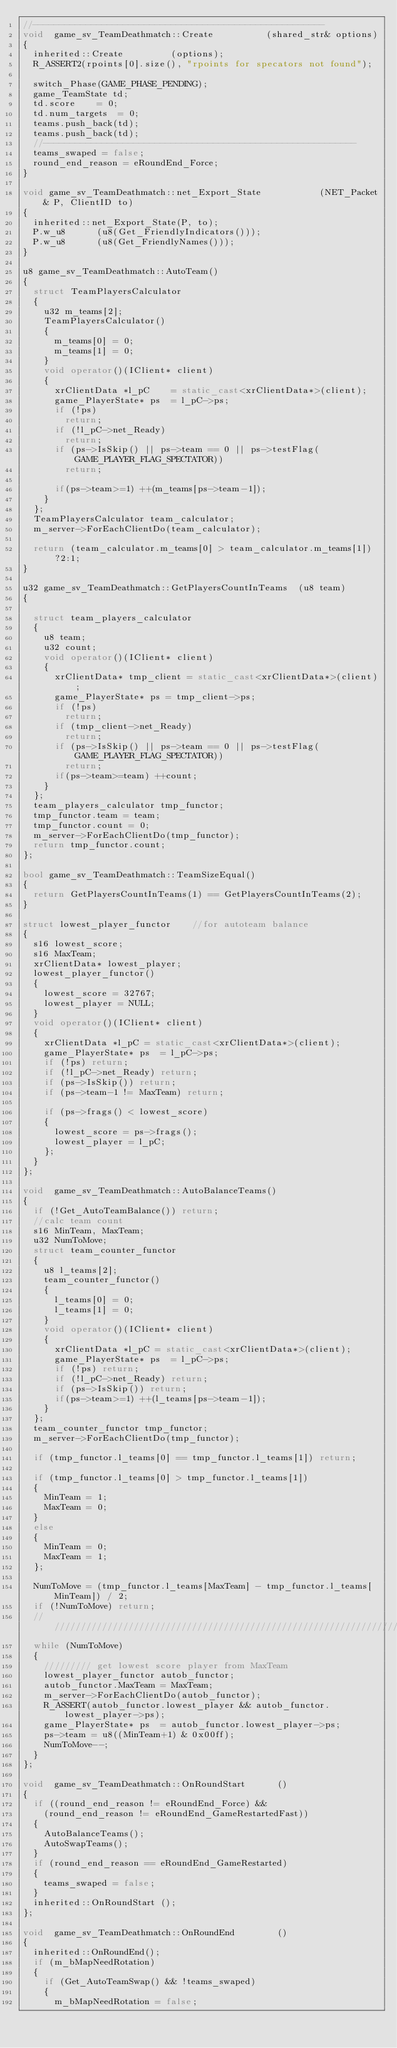<code> <loc_0><loc_0><loc_500><loc_500><_C++_>//-------------------------------------------------------
void	game_sv_TeamDeathmatch::Create					(shared_str& options)
{
	inherited::Create					(options);
	R_ASSERT2(rpoints[0].size(), "rpoints for specators not found");
	
	switch_Phase(GAME_PHASE_PENDING);
	game_TeamState td;
	td.score		= 0;
	td.num_targets	= 0;
	teams.push_back(td);
	teams.push_back(td);
	//-----------------------------------------------------------
	teams_swaped = false;
	round_end_reason = eRoundEnd_Force;
}

void game_sv_TeamDeathmatch::net_Export_State						(NET_Packet& P, ClientID to)
{
	inherited::net_Export_State(P, to);
	P.w_u8			(u8(Get_FriendlyIndicators()));
	P.w_u8			(u8(Get_FriendlyNames()));
}

u8 game_sv_TeamDeathmatch::AutoTeam() 
{
	struct TeamPlayersCalculator
	{
		u32	m_teams[2];
		TeamPlayersCalculator()
		{
			m_teams[0] = 0;
			m_teams[1] = 0;
		}
		void operator()(IClient* client)
		{
			xrClientData *l_pC		= static_cast<xrClientData*>(client);
			game_PlayerState* ps	= l_pC->ps;
			if (!ps)
				return;
			if (!l_pC->net_Ready)
				return;
			if (ps->IsSkip() || ps->team == 0 || ps->testFlag(GAME_PLAYER_FLAG_SPECTATOR))
				return;
			
			if(ps->team>=1) ++(m_teams[ps->team-1]);
		}
	};
	TeamPlayersCalculator team_calculator;
	m_server->ForEachClientDo(team_calculator);
	
	return (team_calculator.m_teams[0] > team_calculator.m_teams[1])?2:1;
}

u32 game_sv_TeamDeathmatch::GetPlayersCountInTeams	(u8 team)
{
	
	struct team_players_calculator
	{
		u8 team;
		u32 count;
		void operator()(IClient* client)
		{
			xrClientData* tmp_client = static_cast<xrClientData*>(client);
			game_PlayerState* ps = tmp_client->ps;
			if (!ps)
				return;
			if (tmp_client->net_Ready)
				return;
			if (ps->IsSkip() || ps->team == 0 || ps->testFlag(GAME_PLAYER_FLAG_SPECTATOR))
				return;
			if(ps->team>=team) ++count;
		}
	};
	team_players_calculator tmp_functor;
	tmp_functor.team = team;
	tmp_functor.count = 0;
	m_server->ForEachClientDo(tmp_functor);
	return tmp_functor.count;
};

bool game_sv_TeamDeathmatch::TeamSizeEqual()
{
	return GetPlayersCountInTeams(1) == GetPlayersCountInTeams(2);
}

struct lowest_player_functor		//for autoteam balance
{
	s16 lowest_score;
	s16 MaxTeam;
	xrClientData* lowest_player;
	lowest_player_functor()
	{
		lowest_score = 32767;
		lowest_player = NULL;
	}
	void operator()(IClient* client)
	{
		xrClientData *l_pC = static_cast<xrClientData*>(client);
		game_PlayerState* ps	= l_pC->ps;
		if (!ps) return;
		if (!l_pC->net_Ready) return;
		if (ps->IsSkip()) return;
		if (ps->team-1 != MaxTeam) return;

		if (ps->frags() < lowest_score)
		{
			lowest_score = ps->frags();
			lowest_player = l_pC;
		};
	}
};

void	game_sv_TeamDeathmatch::AutoBalanceTeams()
{
	if (!Get_AutoTeamBalance()) return;
	//calc team count
	s16 MinTeam, MaxTeam;
	u32 NumToMove;
	struct team_counter_functor
	{
		u8 l_teams[2];
		team_counter_functor()
		{
			l_teams[0] = 0;
			l_teams[1] = 0;
		}
		void operator()(IClient* client)
		{
			xrClientData *l_pC = static_cast<xrClientData*>(client);
			game_PlayerState* ps	= l_pC->ps;
			if (!ps) return;
			if (!l_pC->net_Ready) return;
			if (ps->IsSkip()) return;
			if(ps->team>=1) ++(l_teams[ps->team-1]);
		}
	};
	team_counter_functor tmp_functor;
	m_server->ForEachClientDo(tmp_functor);

	if (tmp_functor.l_teams[0] == tmp_functor.l_teams[1]) return;

	if (tmp_functor.l_teams[0] > tmp_functor.l_teams[1]) 
	{
		MinTeam = 1;
		MaxTeam = 0;
	}
	else
	{
		MinTeam = 0;
		MaxTeam = 1;
	};

	NumToMove = (tmp_functor.l_teams[MaxTeam] - tmp_functor.l_teams[MinTeam]) / 2;
	if (!NumToMove) return;
	///////////////////////////////////////////////////////////////////////
	while (NumToMove)
	{
		///////// get lowest score player from MaxTeam
		lowest_player_functor autob_functor;
		autob_functor.MaxTeam = MaxTeam;
		m_server->ForEachClientDo(autob_functor);
		R_ASSERT(autob_functor.lowest_player && autob_functor.lowest_player->ps);
		game_PlayerState* ps	= autob_functor.lowest_player->ps;
		ps->team = u8((MinTeam+1) & 0x00ff);
		NumToMove--;
	}
};

void	game_sv_TeamDeathmatch::OnRoundStart			()
{
	if ((round_end_reason != eRoundEnd_Force) &&
		(round_end_reason != eRoundEnd_GameRestartedFast))
	{
		AutoBalanceTeams();
		AutoSwapTeams();
	}
	if (round_end_reason == eRoundEnd_GameRestarted)
	{
		teams_swaped = false;
	}
	inherited::OnRoundStart	();
};

void	game_sv_TeamDeathmatch::OnRoundEnd				()
{
	inherited::OnRoundEnd();
	if (m_bMapNeedRotation)
	{
		if (Get_AutoTeamSwap() && !teams_swaped)
		{
			m_bMapNeedRotation = false;</code> 